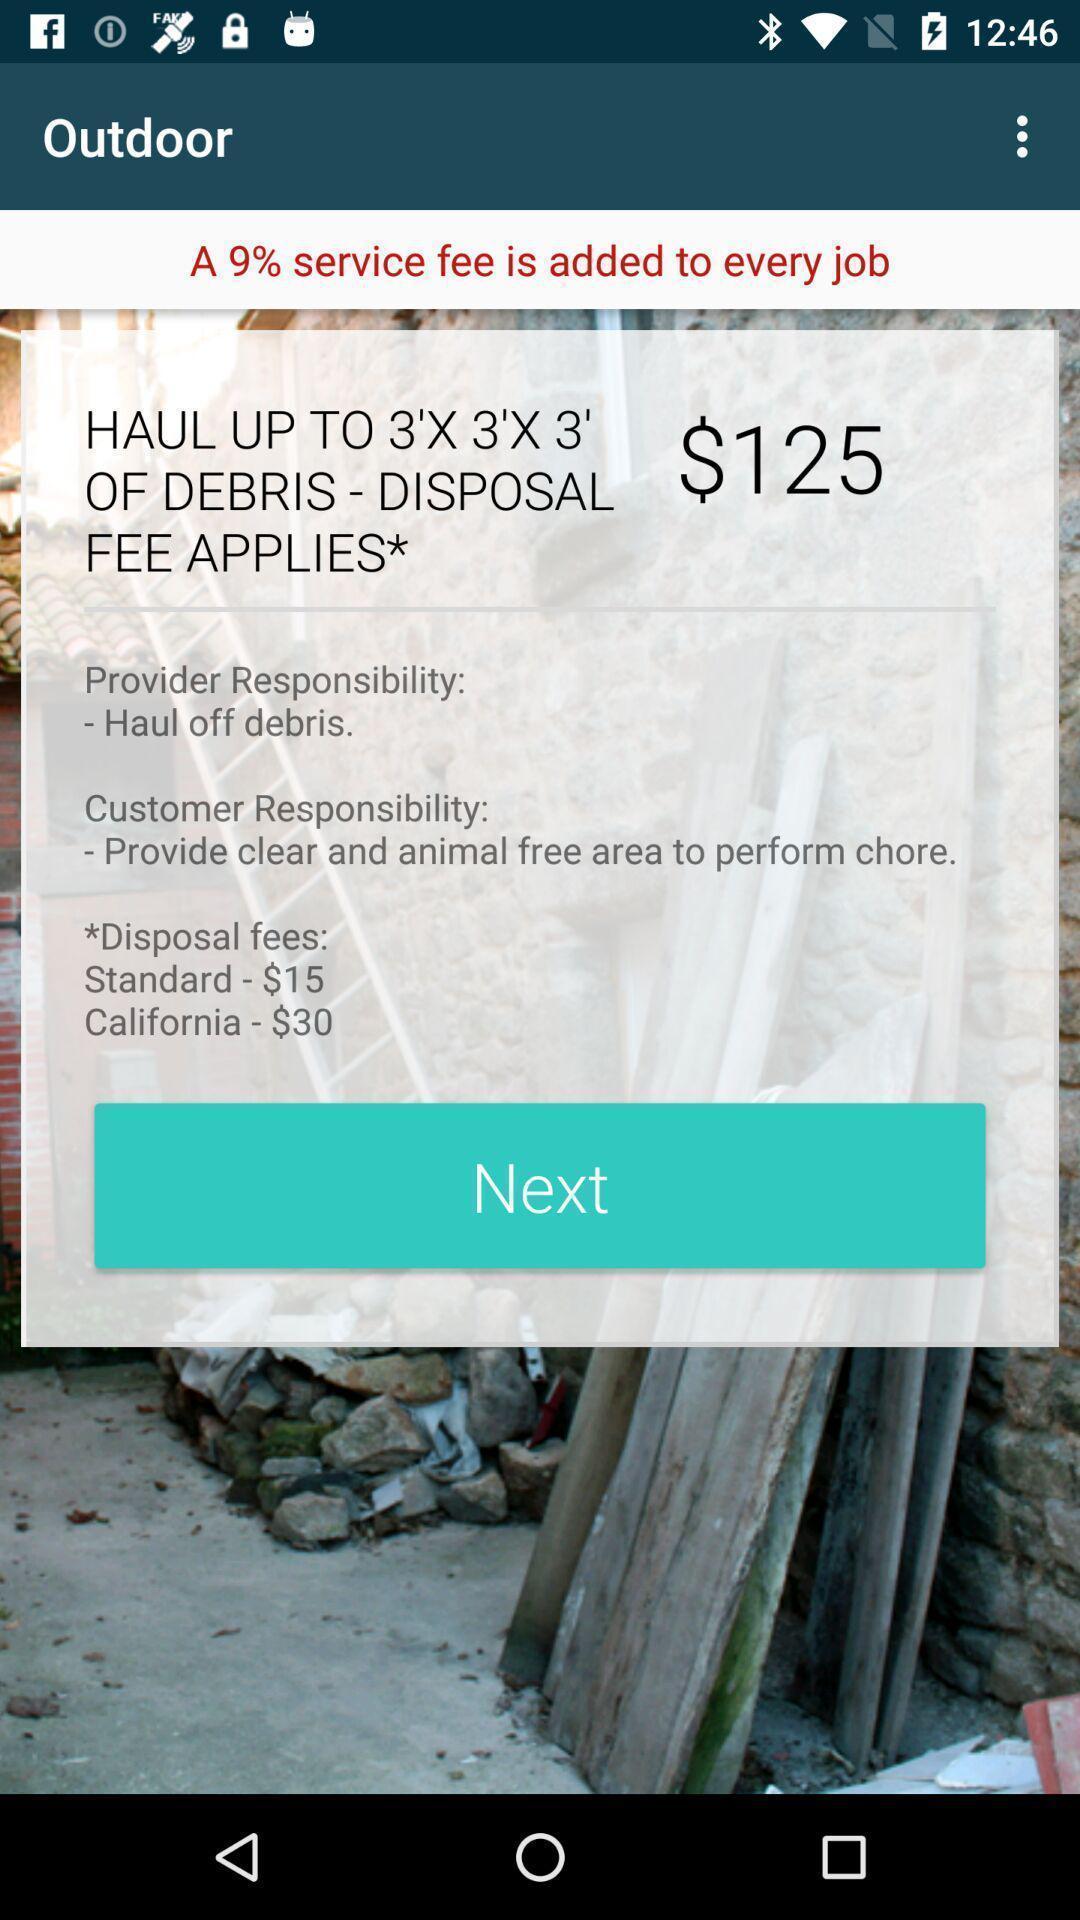What details can you identify in this image? Pop up to service options. 